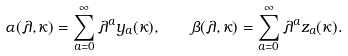Convert formula to latex. <formula><loc_0><loc_0><loc_500><loc_500>\alpha ( \lambda , \kappa ) = \sum _ { a = 0 } ^ { \infty } \lambda ^ { a } y _ { a } ( \kappa ) , \quad \beta ( \lambda , \kappa ) = \sum _ { a = 0 } ^ { \infty } \lambda ^ { a } z _ { a } ( \kappa ) .</formula> 